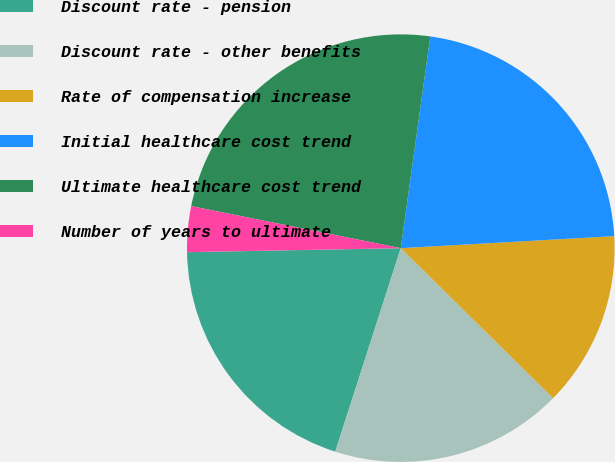Convert chart to OTSL. <chart><loc_0><loc_0><loc_500><loc_500><pie_chart><fcel>Discount rate - pension<fcel>Discount rate - other benefits<fcel>Rate of compensation increase<fcel>Initial healthcare cost trend<fcel>Ultimate healthcare cost trend<fcel>Number of years to ultimate<nl><fcel>19.74%<fcel>17.58%<fcel>13.27%<fcel>21.9%<fcel>24.05%<fcel>3.45%<nl></chart> 